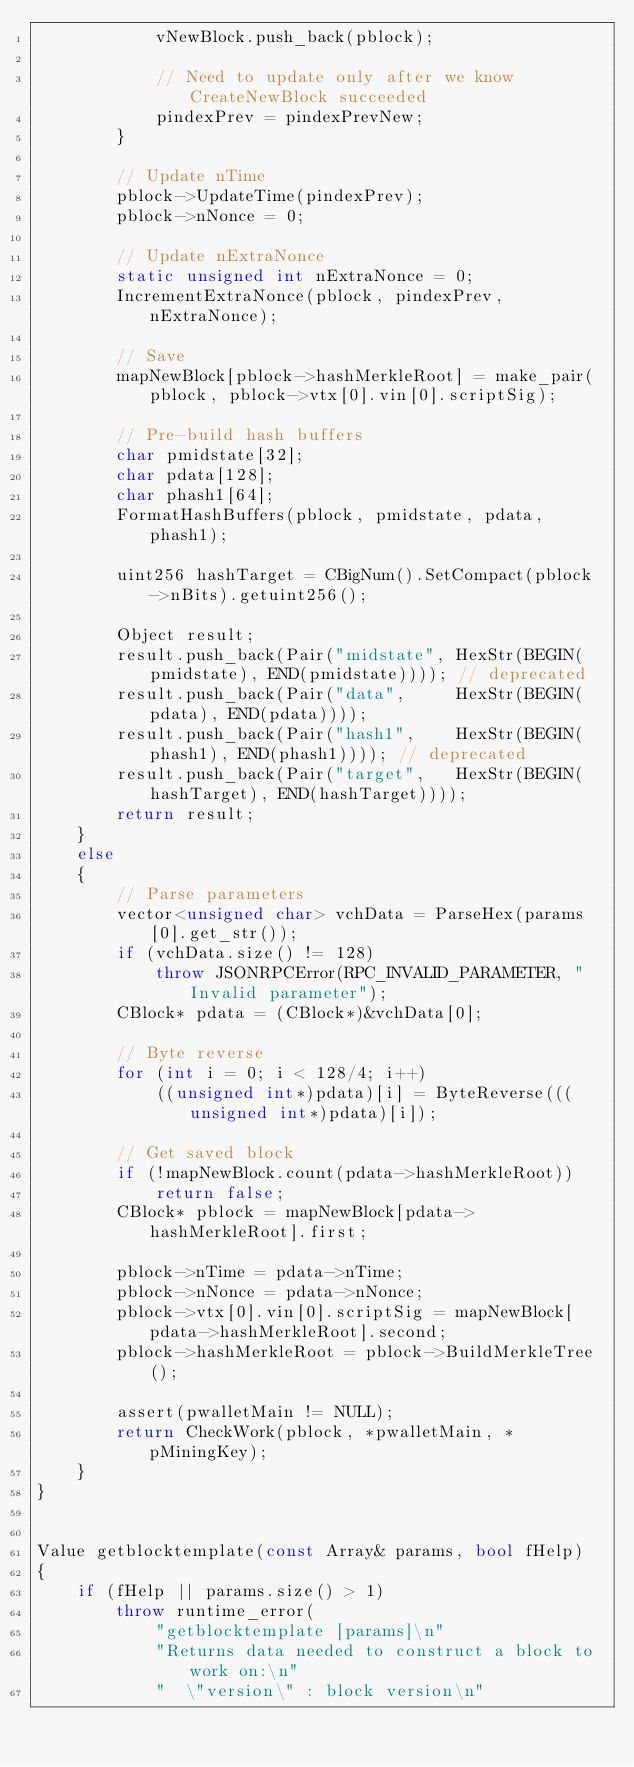Convert code to text. <code><loc_0><loc_0><loc_500><loc_500><_C++_>            vNewBlock.push_back(pblock);

            // Need to update only after we know CreateNewBlock succeeded
            pindexPrev = pindexPrevNew;
        }

        // Update nTime
        pblock->UpdateTime(pindexPrev);
        pblock->nNonce = 0;

        // Update nExtraNonce
        static unsigned int nExtraNonce = 0;
        IncrementExtraNonce(pblock, pindexPrev, nExtraNonce);

        // Save
        mapNewBlock[pblock->hashMerkleRoot] = make_pair(pblock, pblock->vtx[0].vin[0].scriptSig);

        // Pre-build hash buffers
        char pmidstate[32];
        char pdata[128];
        char phash1[64];
        FormatHashBuffers(pblock, pmidstate, pdata, phash1);

        uint256 hashTarget = CBigNum().SetCompact(pblock->nBits).getuint256();

        Object result;
        result.push_back(Pair("midstate", HexStr(BEGIN(pmidstate), END(pmidstate)))); // deprecated
        result.push_back(Pair("data",     HexStr(BEGIN(pdata), END(pdata))));
        result.push_back(Pair("hash1",    HexStr(BEGIN(phash1), END(phash1)))); // deprecated
        result.push_back(Pair("target",   HexStr(BEGIN(hashTarget), END(hashTarget))));
        return result;
    }
    else
    {
        // Parse parameters
        vector<unsigned char> vchData = ParseHex(params[0].get_str());
        if (vchData.size() != 128)
            throw JSONRPCError(RPC_INVALID_PARAMETER, "Invalid parameter");
        CBlock* pdata = (CBlock*)&vchData[0];

        // Byte reverse
        for (int i = 0; i < 128/4; i++)
            ((unsigned int*)pdata)[i] = ByteReverse(((unsigned int*)pdata)[i]);

        // Get saved block
        if (!mapNewBlock.count(pdata->hashMerkleRoot))
            return false;
        CBlock* pblock = mapNewBlock[pdata->hashMerkleRoot].first;

        pblock->nTime = pdata->nTime;
        pblock->nNonce = pdata->nNonce;
        pblock->vtx[0].vin[0].scriptSig = mapNewBlock[pdata->hashMerkleRoot].second;
        pblock->hashMerkleRoot = pblock->BuildMerkleTree();

        assert(pwalletMain != NULL);
        return CheckWork(pblock, *pwalletMain, *pMiningKey);
    }
}


Value getblocktemplate(const Array& params, bool fHelp)
{
    if (fHelp || params.size() > 1)
        throw runtime_error(
            "getblocktemplate [params]\n"
            "Returns data needed to construct a block to work on:\n"
            "  \"version\" : block version\n"</code> 